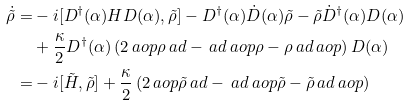Convert formula to latex. <formula><loc_0><loc_0><loc_500><loc_500>\dot { \tilde { \rho } } = & - i [ D ^ { \dag } ( \alpha ) H D ( \alpha ) , \tilde { \rho } ] - D ^ { \dag } ( \alpha ) \dot { D } ( \alpha ) \tilde { \rho } - \tilde { \rho } \dot { D } ^ { \dag } ( \alpha ) D ( \alpha ) \\ & + \frac { \kappa } { 2 } D ^ { \dag } ( \alpha ) \left ( 2 \ a o p \rho \ a d - \ a d \ a o p \rho - \rho \ a d \ a o p \right ) D ( \alpha ) \\ = & - i [ \tilde { H } , \tilde { \rho } ] + \frac { \kappa } { 2 } \left ( 2 \ a o p \tilde { \rho } \ a d - \ a d \ a o p \tilde { \rho } - \tilde { \rho } \ a d \ a o p \right )</formula> 